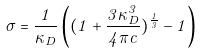<formula> <loc_0><loc_0><loc_500><loc_500>\sigma = \frac { 1 } { \kappa _ { D } } \left ( ( 1 + \frac { 3 \kappa _ { D } ^ { 3 } } { 4 \pi c } ) ^ { \frac { 1 } { 3 } } - 1 \right )</formula> 